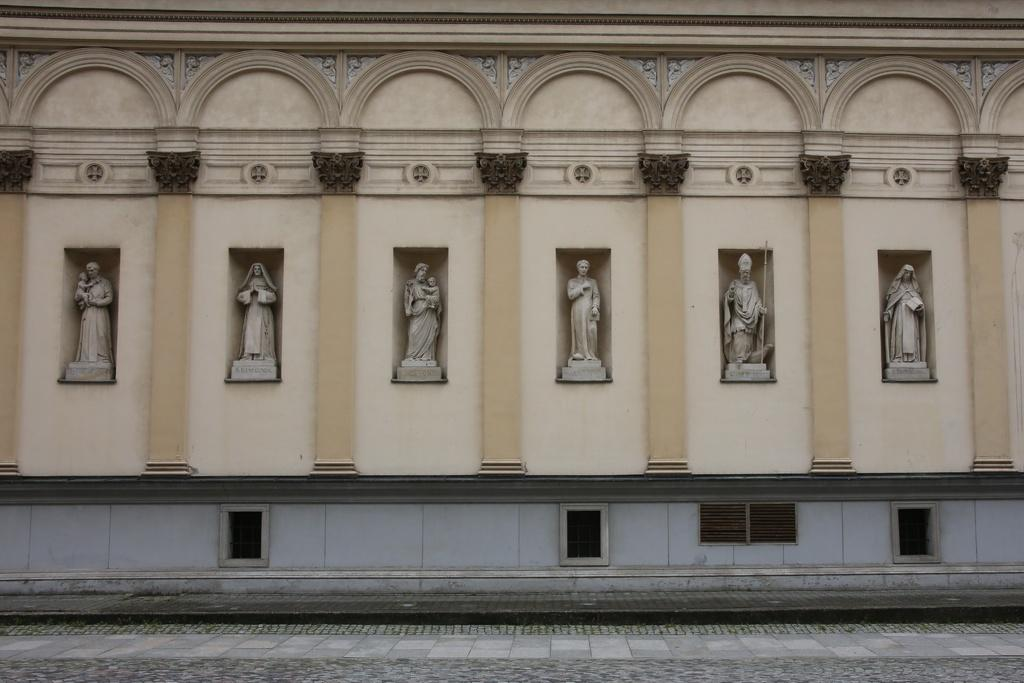What type of structure is visible in the image? There is a building in the image. What other objects can be seen near the building? There are statues in the image. Is there any path or walkway visible in the image? Yes, there is a walkway at the bottom of the image. How many children are playing on the bottle in the image? There is no bottle or children playing on it in the image. 